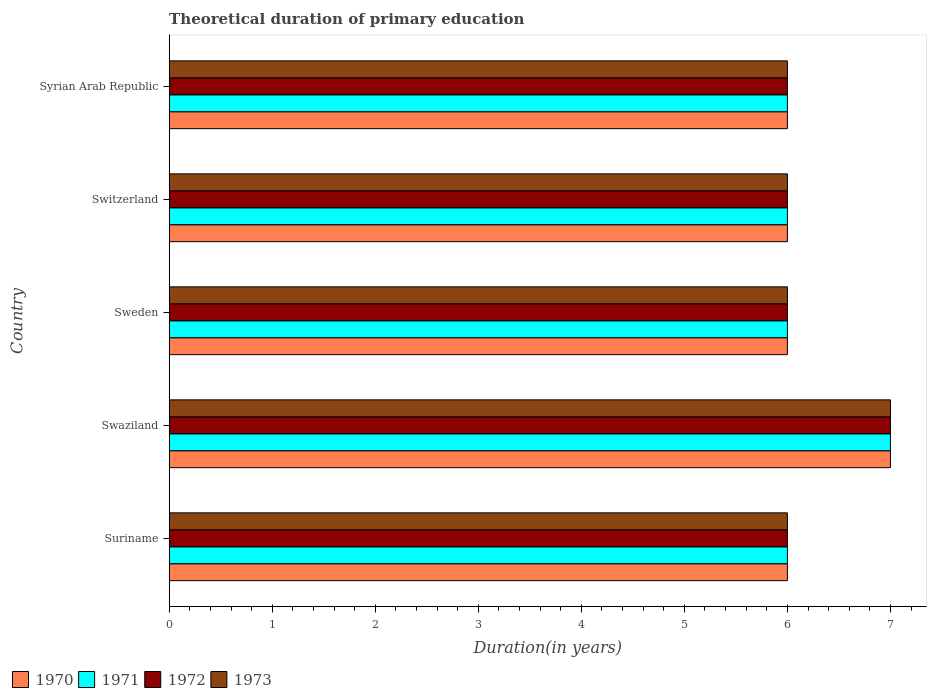How many different coloured bars are there?
Ensure brevity in your answer.  4. How many groups of bars are there?
Provide a succinct answer. 5. Are the number of bars per tick equal to the number of legend labels?
Provide a short and direct response. Yes. Are the number of bars on each tick of the Y-axis equal?
Offer a very short reply. Yes. How many bars are there on the 3rd tick from the top?
Provide a succinct answer. 4. What is the label of the 1st group of bars from the top?
Offer a very short reply. Syrian Arab Republic. In how many cases, is the number of bars for a given country not equal to the number of legend labels?
Give a very brief answer. 0. Across all countries, what is the maximum total theoretical duration of primary education in 1971?
Your answer should be compact. 7. Across all countries, what is the minimum total theoretical duration of primary education in 1970?
Offer a very short reply. 6. In which country was the total theoretical duration of primary education in 1970 maximum?
Keep it short and to the point. Swaziland. In which country was the total theoretical duration of primary education in 1971 minimum?
Make the answer very short. Suriname. What is the total total theoretical duration of primary education in 1970 in the graph?
Your answer should be very brief. 31. What is the difference between the total theoretical duration of primary education in 1971 in Syrian Arab Republic and the total theoretical duration of primary education in 1970 in Suriname?
Provide a short and direct response. 0. What is the ratio of the total theoretical duration of primary education in 1971 in Swaziland to that in Sweden?
Make the answer very short. 1.17. What is the difference between the highest and the second highest total theoretical duration of primary education in 1973?
Your answer should be compact. 1. Is the sum of the total theoretical duration of primary education in 1971 in Suriname and Syrian Arab Republic greater than the maximum total theoretical duration of primary education in 1973 across all countries?
Provide a short and direct response. Yes. Is it the case that in every country, the sum of the total theoretical duration of primary education in 1973 and total theoretical duration of primary education in 1972 is greater than the sum of total theoretical duration of primary education in 1971 and total theoretical duration of primary education in 1970?
Keep it short and to the point. No. What does the 1st bar from the top in Suriname represents?
Your answer should be very brief. 1973. What does the 4th bar from the bottom in Syrian Arab Republic represents?
Provide a succinct answer. 1973. Are all the bars in the graph horizontal?
Provide a succinct answer. Yes. How many countries are there in the graph?
Your answer should be very brief. 5. What is the difference between two consecutive major ticks on the X-axis?
Provide a succinct answer. 1. Are the values on the major ticks of X-axis written in scientific E-notation?
Give a very brief answer. No. Does the graph contain grids?
Your response must be concise. No. How are the legend labels stacked?
Offer a terse response. Horizontal. What is the title of the graph?
Provide a short and direct response. Theoretical duration of primary education. What is the label or title of the X-axis?
Offer a very short reply. Duration(in years). What is the Duration(in years) in 1970 in Suriname?
Offer a very short reply. 6. What is the Duration(in years) in 1972 in Suriname?
Make the answer very short. 6. What is the Duration(in years) of 1973 in Suriname?
Make the answer very short. 6. What is the Duration(in years) in 1970 in Swaziland?
Your answer should be compact. 7. What is the Duration(in years) of 1971 in Sweden?
Ensure brevity in your answer.  6. What is the Duration(in years) in 1972 in Switzerland?
Offer a very short reply. 6. Across all countries, what is the maximum Duration(in years) in 1971?
Give a very brief answer. 7. Across all countries, what is the minimum Duration(in years) in 1973?
Ensure brevity in your answer.  6. What is the total Duration(in years) in 1970 in the graph?
Offer a terse response. 31. What is the total Duration(in years) of 1972 in the graph?
Provide a succinct answer. 31. What is the difference between the Duration(in years) of 1972 in Suriname and that in Swaziland?
Provide a succinct answer. -1. What is the difference between the Duration(in years) of 1973 in Suriname and that in Sweden?
Your answer should be compact. 0. What is the difference between the Duration(in years) in 1970 in Swaziland and that in Sweden?
Offer a very short reply. 1. What is the difference between the Duration(in years) in 1972 in Swaziland and that in Sweden?
Offer a terse response. 1. What is the difference between the Duration(in years) in 1970 in Swaziland and that in Switzerland?
Ensure brevity in your answer.  1. What is the difference between the Duration(in years) of 1971 in Swaziland and that in Switzerland?
Provide a succinct answer. 1. What is the difference between the Duration(in years) in 1972 in Swaziland and that in Switzerland?
Your response must be concise. 1. What is the difference between the Duration(in years) in 1970 in Swaziland and that in Syrian Arab Republic?
Offer a terse response. 1. What is the difference between the Duration(in years) in 1972 in Swaziland and that in Syrian Arab Republic?
Provide a succinct answer. 1. What is the difference between the Duration(in years) in 1971 in Sweden and that in Switzerland?
Make the answer very short. 0. What is the difference between the Duration(in years) of 1973 in Sweden and that in Switzerland?
Make the answer very short. 0. What is the difference between the Duration(in years) in 1972 in Sweden and that in Syrian Arab Republic?
Your response must be concise. 0. What is the difference between the Duration(in years) in 1973 in Sweden and that in Syrian Arab Republic?
Provide a short and direct response. 0. What is the difference between the Duration(in years) in 1970 in Switzerland and that in Syrian Arab Republic?
Make the answer very short. 0. What is the difference between the Duration(in years) of 1970 in Suriname and the Duration(in years) of 1973 in Swaziland?
Offer a very short reply. -1. What is the difference between the Duration(in years) in 1971 in Suriname and the Duration(in years) in 1972 in Swaziland?
Offer a very short reply. -1. What is the difference between the Duration(in years) in 1972 in Suriname and the Duration(in years) in 1973 in Swaziland?
Ensure brevity in your answer.  -1. What is the difference between the Duration(in years) of 1970 in Suriname and the Duration(in years) of 1971 in Sweden?
Give a very brief answer. 0. What is the difference between the Duration(in years) in 1970 in Suriname and the Duration(in years) in 1972 in Sweden?
Your answer should be very brief. 0. What is the difference between the Duration(in years) of 1972 in Suriname and the Duration(in years) of 1973 in Sweden?
Your response must be concise. 0. What is the difference between the Duration(in years) in 1970 in Suriname and the Duration(in years) in 1973 in Switzerland?
Your answer should be very brief. 0. What is the difference between the Duration(in years) in 1970 in Suriname and the Duration(in years) in 1972 in Syrian Arab Republic?
Your response must be concise. 0. What is the difference between the Duration(in years) of 1971 in Suriname and the Duration(in years) of 1972 in Syrian Arab Republic?
Your answer should be very brief. 0. What is the difference between the Duration(in years) of 1970 in Swaziland and the Duration(in years) of 1972 in Sweden?
Offer a terse response. 1. What is the difference between the Duration(in years) in 1970 in Swaziland and the Duration(in years) in 1973 in Sweden?
Your answer should be very brief. 1. What is the difference between the Duration(in years) of 1972 in Swaziland and the Duration(in years) of 1973 in Sweden?
Offer a very short reply. 1. What is the difference between the Duration(in years) of 1970 in Swaziland and the Duration(in years) of 1971 in Switzerland?
Provide a short and direct response. 1. What is the difference between the Duration(in years) of 1970 in Swaziland and the Duration(in years) of 1972 in Switzerland?
Ensure brevity in your answer.  1. What is the difference between the Duration(in years) in 1970 in Swaziland and the Duration(in years) in 1971 in Syrian Arab Republic?
Offer a terse response. 1. What is the difference between the Duration(in years) of 1970 in Swaziland and the Duration(in years) of 1973 in Syrian Arab Republic?
Offer a terse response. 1. What is the difference between the Duration(in years) in 1972 in Swaziland and the Duration(in years) in 1973 in Syrian Arab Republic?
Give a very brief answer. 1. What is the difference between the Duration(in years) of 1970 in Sweden and the Duration(in years) of 1972 in Switzerland?
Your answer should be compact. 0. What is the difference between the Duration(in years) in 1970 in Sweden and the Duration(in years) in 1973 in Switzerland?
Your answer should be compact. 0. What is the difference between the Duration(in years) in 1970 in Sweden and the Duration(in years) in 1972 in Syrian Arab Republic?
Give a very brief answer. 0. What is the difference between the Duration(in years) of 1970 in Sweden and the Duration(in years) of 1973 in Syrian Arab Republic?
Provide a succinct answer. 0. What is the difference between the Duration(in years) in 1971 in Sweden and the Duration(in years) in 1973 in Syrian Arab Republic?
Offer a very short reply. 0. What is the difference between the Duration(in years) in 1970 in Switzerland and the Duration(in years) in 1971 in Syrian Arab Republic?
Give a very brief answer. 0. What is the difference between the Duration(in years) in 1970 in Switzerland and the Duration(in years) in 1972 in Syrian Arab Republic?
Make the answer very short. 0. What is the difference between the Duration(in years) of 1970 in Switzerland and the Duration(in years) of 1973 in Syrian Arab Republic?
Your response must be concise. 0. What is the difference between the Duration(in years) in 1971 in Switzerland and the Duration(in years) in 1972 in Syrian Arab Republic?
Your answer should be very brief. 0. What is the difference between the Duration(in years) in 1971 in Switzerland and the Duration(in years) in 1973 in Syrian Arab Republic?
Offer a very short reply. 0. What is the difference between the Duration(in years) of 1972 in Switzerland and the Duration(in years) of 1973 in Syrian Arab Republic?
Ensure brevity in your answer.  0. What is the average Duration(in years) in 1971 per country?
Give a very brief answer. 6.2. What is the average Duration(in years) of 1972 per country?
Your answer should be very brief. 6.2. What is the average Duration(in years) in 1973 per country?
Keep it short and to the point. 6.2. What is the difference between the Duration(in years) in 1970 and Duration(in years) in 1972 in Suriname?
Your answer should be very brief. 0. What is the difference between the Duration(in years) in 1970 and Duration(in years) in 1973 in Suriname?
Your answer should be very brief. 0. What is the difference between the Duration(in years) of 1971 and Duration(in years) of 1972 in Suriname?
Your response must be concise. 0. What is the difference between the Duration(in years) in 1972 and Duration(in years) in 1973 in Suriname?
Provide a succinct answer. 0. What is the difference between the Duration(in years) in 1970 and Duration(in years) in 1971 in Swaziland?
Ensure brevity in your answer.  0. What is the difference between the Duration(in years) in 1971 and Duration(in years) in 1973 in Swaziland?
Make the answer very short. 0. What is the difference between the Duration(in years) of 1972 and Duration(in years) of 1973 in Swaziland?
Ensure brevity in your answer.  0. What is the difference between the Duration(in years) of 1972 and Duration(in years) of 1973 in Sweden?
Your answer should be very brief. 0. What is the difference between the Duration(in years) of 1970 and Duration(in years) of 1973 in Switzerland?
Your answer should be very brief. 0. What is the difference between the Duration(in years) of 1971 and Duration(in years) of 1972 in Switzerland?
Your answer should be compact. 0. What is the difference between the Duration(in years) in 1971 and Duration(in years) in 1973 in Switzerland?
Offer a very short reply. 0. What is the difference between the Duration(in years) of 1972 and Duration(in years) of 1973 in Switzerland?
Offer a very short reply. 0. What is the difference between the Duration(in years) of 1970 and Duration(in years) of 1972 in Syrian Arab Republic?
Your answer should be compact. 0. What is the difference between the Duration(in years) of 1970 and Duration(in years) of 1973 in Syrian Arab Republic?
Provide a succinct answer. 0. What is the difference between the Duration(in years) in 1972 and Duration(in years) in 1973 in Syrian Arab Republic?
Keep it short and to the point. 0. What is the ratio of the Duration(in years) of 1970 in Suriname to that in Swaziland?
Your response must be concise. 0.86. What is the ratio of the Duration(in years) of 1971 in Suriname to that in Swaziland?
Offer a very short reply. 0.86. What is the ratio of the Duration(in years) of 1973 in Suriname to that in Swaziland?
Offer a very short reply. 0.86. What is the ratio of the Duration(in years) of 1971 in Suriname to that in Sweden?
Offer a very short reply. 1. What is the ratio of the Duration(in years) in 1972 in Suriname to that in Sweden?
Provide a short and direct response. 1. What is the ratio of the Duration(in years) in 1973 in Suriname to that in Sweden?
Offer a very short reply. 1. What is the ratio of the Duration(in years) of 1970 in Suriname to that in Switzerland?
Provide a succinct answer. 1. What is the ratio of the Duration(in years) of 1972 in Suriname to that in Switzerland?
Make the answer very short. 1. What is the ratio of the Duration(in years) of 1973 in Suriname to that in Switzerland?
Give a very brief answer. 1. What is the ratio of the Duration(in years) in 1972 in Suriname to that in Syrian Arab Republic?
Provide a short and direct response. 1. What is the ratio of the Duration(in years) of 1971 in Swaziland to that in Sweden?
Give a very brief answer. 1.17. What is the ratio of the Duration(in years) of 1972 in Swaziland to that in Sweden?
Your response must be concise. 1.17. What is the ratio of the Duration(in years) of 1973 in Swaziland to that in Sweden?
Your response must be concise. 1.17. What is the ratio of the Duration(in years) in 1970 in Swaziland to that in Switzerland?
Make the answer very short. 1.17. What is the ratio of the Duration(in years) of 1970 in Swaziland to that in Syrian Arab Republic?
Give a very brief answer. 1.17. What is the ratio of the Duration(in years) in 1971 in Swaziland to that in Syrian Arab Republic?
Offer a terse response. 1.17. What is the ratio of the Duration(in years) in 1971 in Sweden to that in Switzerland?
Your answer should be compact. 1. What is the ratio of the Duration(in years) in 1972 in Sweden to that in Switzerland?
Offer a terse response. 1. What is the ratio of the Duration(in years) in 1970 in Sweden to that in Syrian Arab Republic?
Offer a terse response. 1. What is the ratio of the Duration(in years) in 1971 in Sweden to that in Syrian Arab Republic?
Provide a short and direct response. 1. What is the ratio of the Duration(in years) in 1972 in Sweden to that in Syrian Arab Republic?
Your answer should be compact. 1. What is the ratio of the Duration(in years) in 1973 in Sweden to that in Syrian Arab Republic?
Your answer should be very brief. 1. What is the ratio of the Duration(in years) in 1971 in Switzerland to that in Syrian Arab Republic?
Provide a succinct answer. 1. What is the ratio of the Duration(in years) in 1972 in Switzerland to that in Syrian Arab Republic?
Make the answer very short. 1. What is the difference between the highest and the second highest Duration(in years) in 1971?
Keep it short and to the point. 1. What is the difference between the highest and the lowest Duration(in years) in 1970?
Make the answer very short. 1. What is the difference between the highest and the lowest Duration(in years) in 1971?
Make the answer very short. 1. What is the difference between the highest and the lowest Duration(in years) of 1972?
Provide a short and direct response. 1. 